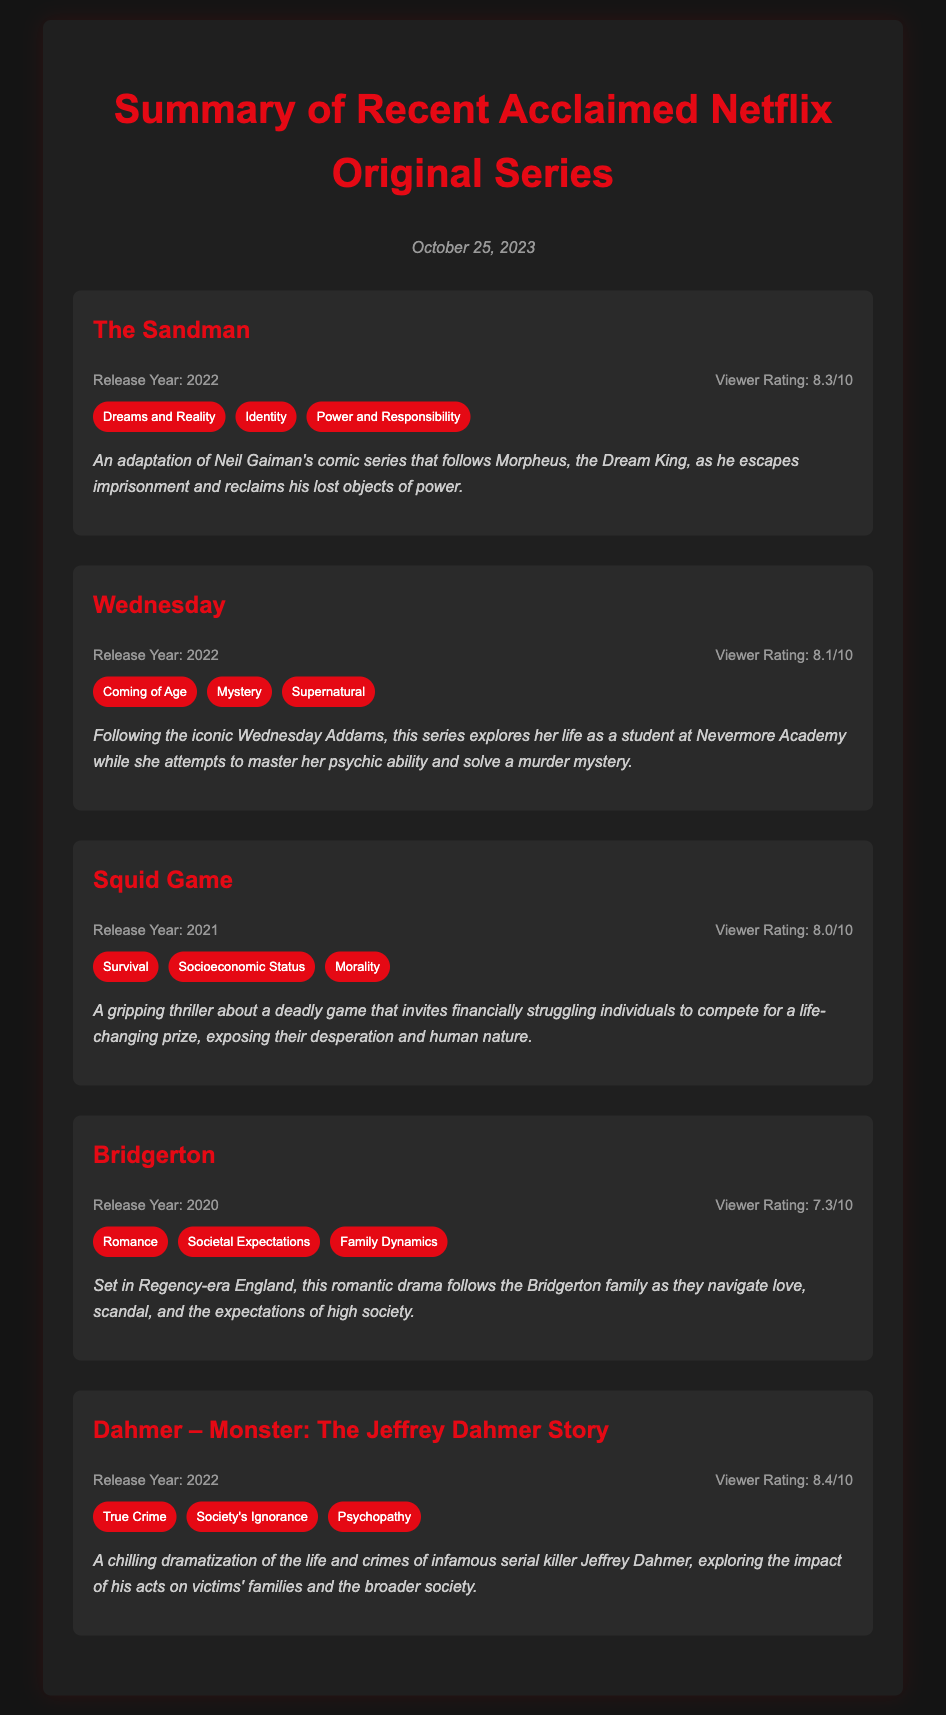What is the highest viewer rating among the series? "Dahmer – Monster: The Jeffrey Dahmer Story" has the highest viewer rating of 8.4/10.
Answer: 8.4/10 Which series was released in 2022? Three series, "The Sandman," "Wednesday," and "Dahmer – Monster: The Jeffrey Dahmer Story," were released in 2022.
Answer: The Sandman, Wednesday, Dahmer – Monster: The Jeffrey Dahmer Story What theme is associated with "Squid Game"? The theme "Survival" is associated with "Squid Game".
Answer: Survival How many series are listed in the document? There are five series listed in the document.
Answer: Five What is the release year of "Bridgerton"? "Bridgerton" was released in 2020.
Answer: 2020 Which series features themes of "Coming of Age" and "Supernatural"? "Wednesday" features themes of "Coming of Age" and "Supernatural".
Answer: Wednesday What is the summary focus of "The Sandman"? The summary focuses on Morpheus, the Dream King, attempting to reclaim his lost power.
Answer: Morpheus reclaiming lost power What is the viewer rating of "Bridgerton"? "Bridgerton" has a viewer rating of 7.3/10.
Answer: 7.3/10 